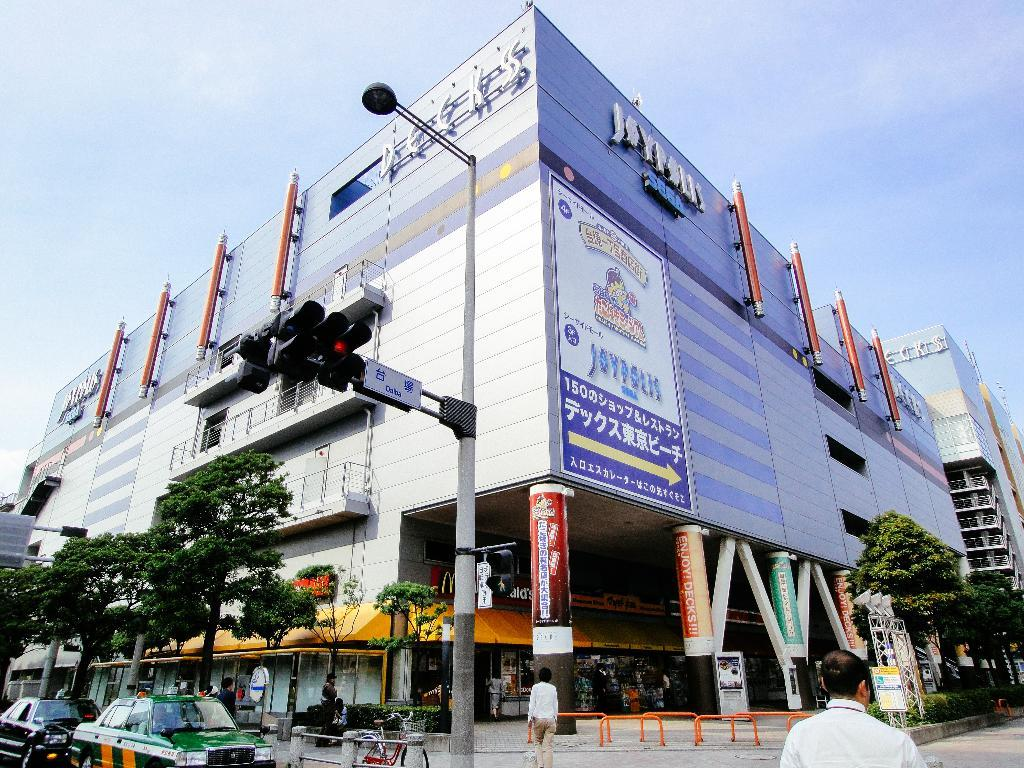What type of vehicles can be seen in the image? There are cars in the image. What structures are present in the image? There are poles, traffic signals, trees, boards, hoardings, and buildings in the image. Are there any people visible in the image? Yes, there are persons in the image. What can be seen in the background of the image? The sky is visible in the background of the image. What type of health issues are the persons in the image experiencing? There is no information about the health of the persons in the image, so we cannot determine if they are experiencing any health issues. Can you tell me how many cables are connected to the traffic signals in the image? There is no mention of cables connected to the traffic signals in the image, so we cannot determine the number of cables. 